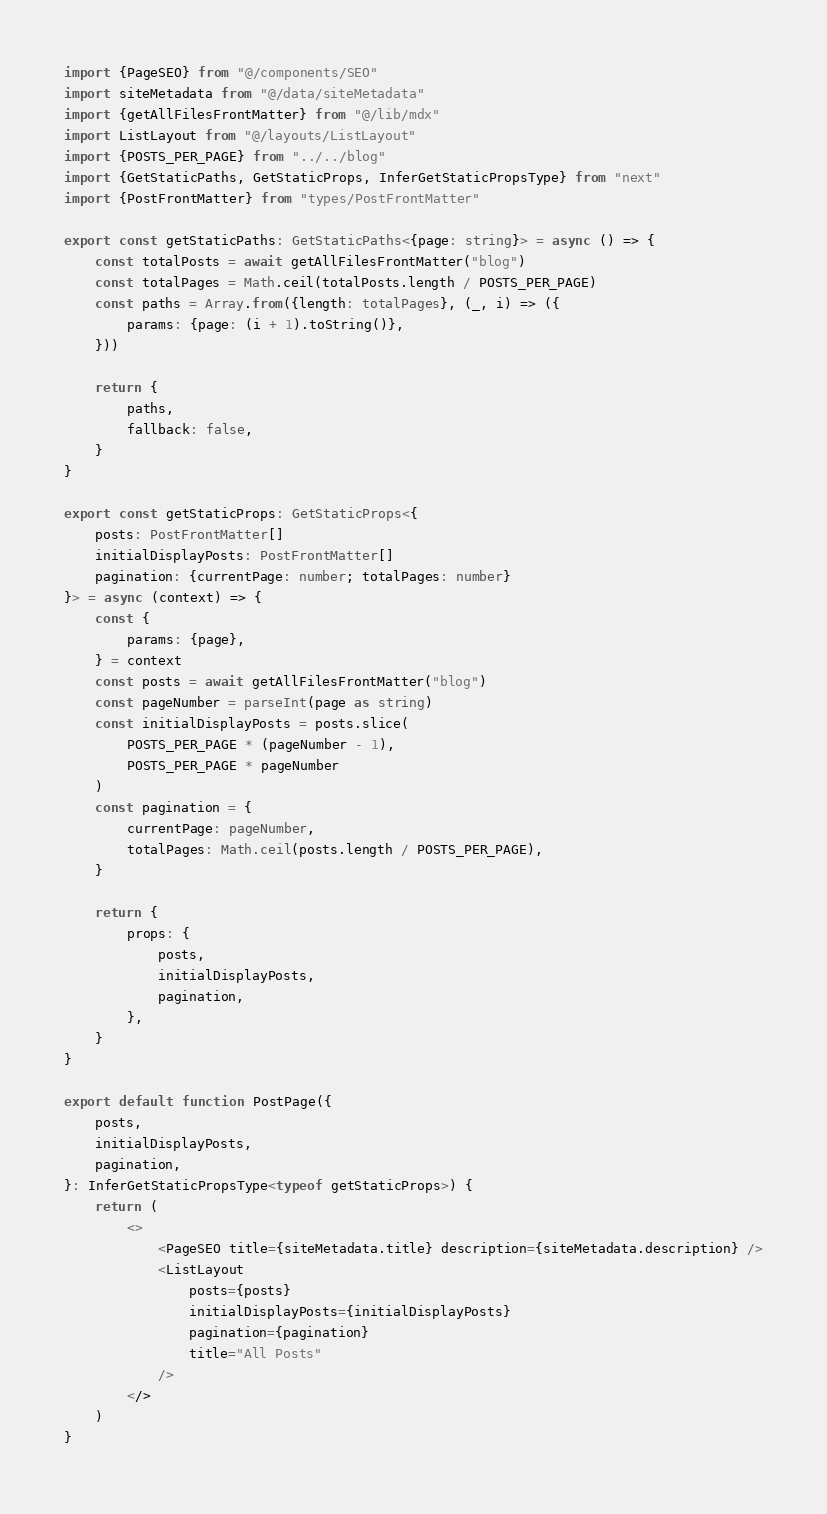<code> <loc_0><loc_0><loc_500><loc_500><_TypeScript_>import {PageSEO} from "@/components/SEO"
import siteMetadata from "@/data/siteMetadata"
import {getAllFilesFrontMatter} from "@/lib/mdx"
import ListLayout from "@/layouts/ListLayout"
import {POSTS_PER_PAGE} from "../../blog"
import {GetStaticPaths, GetStaticProps, InferGetStaticPropsType} from "next"
import {PostFrontMatter} from "types/PostFrontMatter"

export const getStaticPaths: GetStaticPaths<{page: string}> = async () => {
	const totalPosts = await getAllFilesFrontMatter("blog")
	const totalPages = Math.ceil(totalPosts.length / POSTS_PER_PAGE)
	const paths = Array.from({length: totalPages}, (_, i) => ({
		params: {page: (i + 1).toString()},
	}))

	return {
		paths,
		fallback: false,
	}
}

export const getStaticProps: GetStaticProps<{
	posts: PostFrontMatter[]
	initialDisplayPosts: PostFrontMatter[]
	pagination: {currentPage: number; totalPages: number}
}> = async (context) => {
	const {
		params: {page},
	} = context
	const posts = await getAllFilesFrontMatter("blog")
	const pageNumber = parseInt(page as string)
	const initialDisplayPosts = posts.slice(
		POSTS_PER_PAGE * (pageNumber - 1),
		POSTS_PER_PAGE * pageNumber
	)
	const pagination = {
		currentPage: pageNumber,
		totalPages: Math.ceil(posts.length / POSTS_PER_PAGE),
	}

	return {
		props: {
			posts,
			initialDisplayPosts,
			pagination,
		},
	}
}

export default function PostPage({
	posts,
	initialDisplayPosts,
	pagination,
}: InferGetStaticPropsType<typeof getStaticProps>) {
	return (
		<>
			<PageSEO title={siteMetadata.title} description={siteMetadata.description} />
			<ListLayout
				posts={posts}
				initialDisplayPosts={initialDisplayPosts}
				pagination={pagination}
				title="All Posts"
			/>
		</>
	)
}
</code> 